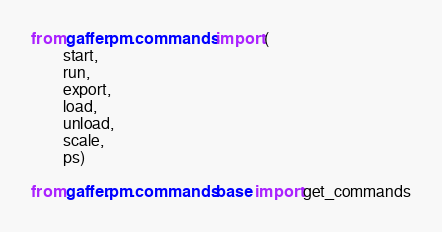Convert code to text. <code><loc_0><loc_0><loc_500><loc_500><_Python_>from gaffer.pm.commands import (
        start,
        run,
        export,
        load,
        unload,
        scale,
        ps)

from gaffer.pm.commands.base import get_commands
</code> 